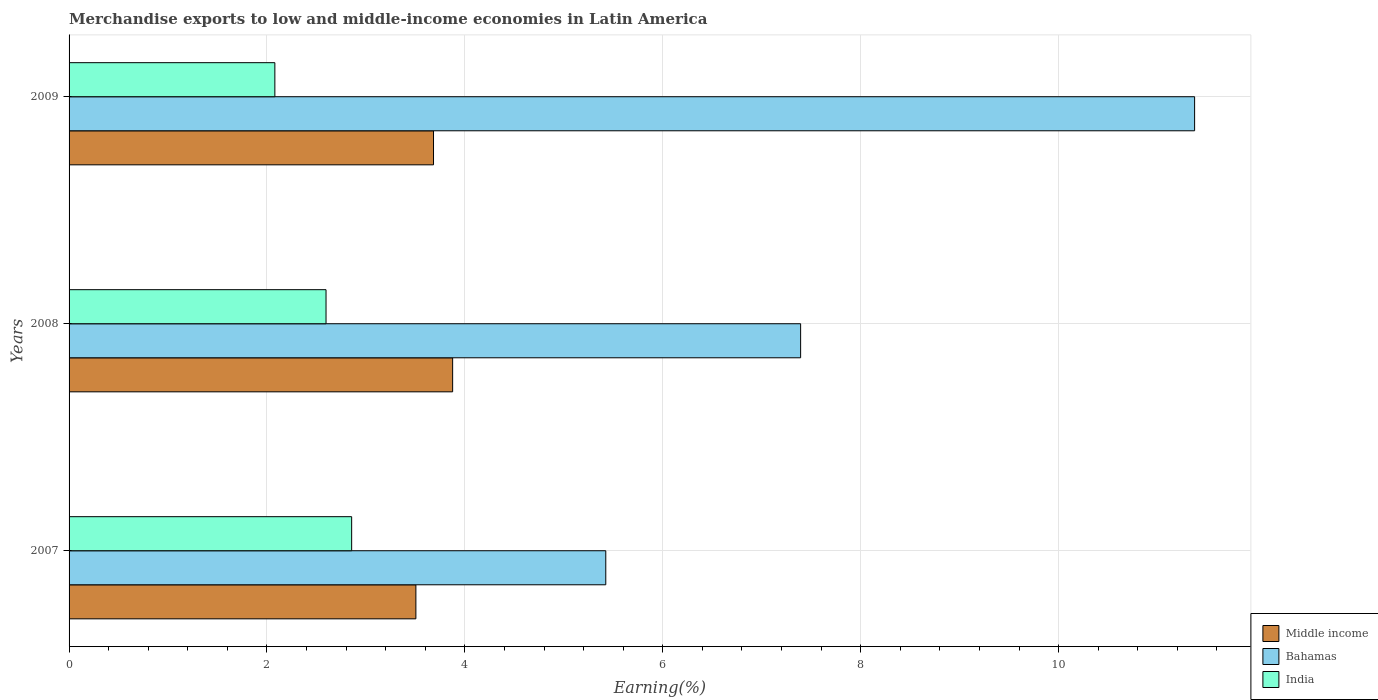How many different coloured bars are there?
Make the answer very short. 3. Are the number of bars per tick equal to the number of legend labels?
Ensure brevity in your answer.  Yes. Are the number of bars on each tick of the Y-axis equal?
Provide a short and direct response. Yes. How many bars are there on the 2nd tick from the top?
Make the answer very short. 3. How many bars are there on the 2nd tick from the bottom?
Provide a short and direct response. 3. In how many cases, is the number of bars for a given year not equal to the number of legend labels?
Make the answer very short. 0. What is the percentage of amount earned from merchandise exports in Bahamas in 2007?
Make the answer very short. 5.42. Across all years, what is the maximum percentage of amount earned from merchandise exports in Middle income?
Offer a very short reply. 3.88. Across all years, what is the minimum percentage of amount earned from merchandise exports in Middle income?
Offer a terse response. 3.5. In which year was the percentage of amount earned from merchandise exports in India maximum?
Your answer should be very brief. 2007. What is the total percentage of amount earned from merchandise exports in Middle income in the graph?
Offer a very short reply. 11.06. What is the difference between the percentage of amount earned from merchandise exports in Bahamas in 2008 and that in 2009?
Provide a short and direct response. -3.98. What is the difference between the percentage of amount earned from merchandise exports in India in 2009 and the percentage of amount earned from merchandise exports in Middle income in 2007?
Keep it short and to the point. -1.43. What is the average percentage of amount earned from merchandise exports in Bahamas per year?
Provide a succinct answer. 8.06. In the year 2009, what is the difference between the percentage of amount earned from merchandise exports in India and percentage of amount earned from merchandise exports in Bahamas?
Your answer should be compact. -9.29. In how many years, is the percentage of amount earned from merchandise exports in Bahamas greater than 9.2 %?
Provide a short and direct response. 1. What is the ratio of the percentage of amount earned from merchandise exports in Bahamas in 2007 to that in 2009?
Provide a succinct answer. 0.48. What is the difference between the highest and the second highest percentage of amount earned from merchandise exports in India?
Provide a succinct answer. 0.26. What is the difference between the highest and the lowest percentage of amount earned from merchandise exports in Middle income?
Ensure brevity in your answer.  0.37. Is it the case that in every year, the sum of the percentage of amount earned from merchandise exports in Middle income and percentage of amount earned from merchandise exports in Bahamas is greater than the percentage of amount earned from merchandise exports in India?
Provide a short and direct response. Yes. Are all the bars in the graph horizontal?
Your answer should be very brief. Yes. How many years are there in the graph?
Provide a short and direct response. 3. What is the difference between two consecutive major ticks on the X-axis?
Your answer should be very brief. 2. Are the values on the major ticks of X-axis written in scientific E-notation?
Your answer should be compact. No. Does the graph contain any zero values?
Provide a short and direct response. No. Does the graph contain grids?
Provide a short and direct response. Yes. Where does the legend appear in the graph?
Provide a succinct answer. Bottom right. How are the legend labels stacked?
Ensure brevity in your answer.  Vertical. What is the title of the graph?
Keep it short and to the point. Merchandise exports to low and middle-income economies in Latin America. What is the label or title of the X-axis?
Make the answer very short. Earning(%). What is the label or title of the Y-axis?
Offer a terse response. Years. What is the Earning(%) in Middle income in 2007?
Offer a terse response. 3.5. What is the Earning(%) of Bahamas in 2007?
Make the answer very short. 5.42. What is the Earning(%) of India in 2007?
Offer a very short reply. 2.86. What is the Earning(%) in Middle income in 2008?
Ensure brevity in your answer.  3.88. What is the Earning(%) of Bahamas in 2008?
Offer a terse response. 7.39. What is the Earning(%) of India in 2008?
Offer a terse response. 2.6. What is the Earning(%) in Middle income in 2009?
Provide a succinct answer. 3.68. What is the Earning(%) in Bahamas in 2009?
Make the answer very short. 11.37. What is the Earning(%) of India in 2009?
Ensure brevity in your answer.  2.08. Across all years, what is the maximum Earning(%) of Middle income?
Provide a succinct answer. 3.88. Across all years, what is the maximum Earning(%) in Bahamas?
Provide a succinct answer. 11.37. Across all years, what is the maximum Earning(%) of India?
Provide a short and direct response. 2.86. Across all years, what is the minimum Earning(%) of Middle income?
Keep it short and to the point. 3.5. Across all years, what is the minimum Earning(%) of Bahamas?
Provide a succinct answer. 5.42. Across all years, what is the minimum Earning(%) in India?
Give a very brief answer. 2.08. What is the total Earning(%) of Middle income in the graph?
Keep it short and to the point. 11.06. What is the total Earning(%) in Bahamas in the graph?
Keep it short and to the point. 24.19. What is the total Earning(%) of India in the graph?
Provide a short and direct response. 7.53. What is the difference between the Earning(%) in Middle income in 2007 and that in 2008?
Your answer should be compact. -0.37. What is the difference between the Earning(%) of Bahamas in 2007 and that in 2008?
Provide a succinct answer. -1.97. What is the difference between the Earning(%) of India in 2007 and that in 2008?
Make the answer very short. 0.26. What is the difference between the Earning(%) of Middle income in 2007 and that in 2009?
Make the answer very short. -0.18. What is the difference between the Earning(%) in Bahamas in 2007 and that in 2009?
Keep it short and to the point. -5.95. What is the difference between the Earning(%) in India in 2007 and that in 2009?
Offer a terse response. 0.78. What is the difference between the Earning(%) of Middle income in 2008 and that in 2009?
Your response must be concise. 0.19. What is the difference between the Earning(%) of Bahamas in 2008 and that in 2009?
Your answer should be very brief. -3.98. What is the difference between the Earning(%) of India in 2008 and that in 2009?
Ensure brevity in your answer.  0.52. What is the difference between the Earning(%) in Middle income in 2007 and the Earning(%) in Bahamas in 2008?
Provide a succinct answer. -3.89. What is the difference between the Earning(%) in Middle income in 2007 and the Earning(%) in India in 2008?
Provide a succinct answer. 0.91. What is the difference between the Earning(%) in Bahamas in 2007 and the Earning(%) in India in 2008?
Make the answer very short. 2.83. What is the difference between the Earning(%) of Middle income in 2007 and the Earning(%) of Bahamas in 2009?
Offer a very short reply. -7.87. What is the difference between the Earning(%) of Middle income in 2007 and the Earning(%) of India in 2009?
Provide a short and direct response. 1.43. What is the difference between the Earning(%) in Bahamas in 2007 and the Earning(%) in India in 2009?
Make the answer very short. 3.34. What is the difference between the Earning(%) of Middle income in 2008 and the Earning(%) of Bahamas in 2009?
Your answer should be very brief. -7.5. What is the difference between the Earning(%) of Middle income in 2008 and the Earning(%) of India in 2009?
Offer a very short reply. 1.8. What is the difference between the Earning(%) of Bahamas in 2008 and the Earning(%) of India in 2009?
Your answer should be very brief. 5.31. What is the average Earning(%) in Middle income per year?
Your answer should be very brief. 3.69. What is the average Earning(%) in Bahamas per year?
Offer a very short reply. 8.06. What is the average Earning(%) in India per year?
Your answer should be very brief. 2.51. In the year 2007, what is the difference between the Earning(%) in Middle income and Earning(%) in Bahamas?
Give a very brief answer. -1.92. In the year 2007, what is the difference between the Earning(%) in Middle income and Earning(%) in India?
Keep it short and to the point. 0.65. In the year 2007, what is the difference between the Earning(%) of Bahamas and Earning(%) of India?
Your answer should be very brief. 2.57. In the year 2008, what is the difference between the Earning(%) of Middle income and Earning(%) of Bahamas?
Give a very brief answer. -3.52. In the year 2008, what is the difference between the Earning(%) of Middle income and Earning(%) of India?
Your answer should be compact. 1.28. In the year 2008, what is the difference between the Earning(%) in Bahamas and Earning(%) in India?
Provide a succinct answer. 4.8. In the year 2009, what is the difference between the Earning(%) in Middle income and Earning(%) in Bahamas?
Offer a terse response. -7.69. In the year 2009, what is the difference between the Earning(%) of Middle income and Earning(%) of India?
Offer a terse response. 1.6. In the year 2009, what is the difference between the Earning(%) of Bahamas and Earning(%) of India?
Keep it short and to the point. 9.29. What is the ratio of the Earning(%) in Middle income in 2007 to that in 2008?
Ensure brevity in your answer.  0.9. What is the ratio of the Earning(%) in Bahamas in 2007 to that in 2008?
Your answer should be very brief. 0.73. What is the ratio of the Earning(%) of India in 2007 to that in 2008?
Make the answer very short. 1.1. What is the ratio of the Earning(%) of Middle income in 2007 to that in 2009?
Offer a very short reply. 0.95. What is the ratio of the Earning(%) of Bahamas in 2007 to that in 2009?
Your response must be concise. 0.48. What is the ratio of the Earning(%) of India in 2007 to that in 2009?
Keep it short and to the point. 1.37. What is the ratio of the Earning(%) of Middle income in 2008 to that in 2009?
Your answer should be very brief. 1.05. What is the ratio of the Earning(%) of Bahamas in 2008 to that in 2009?
Give a very brief answer. 0.65. What is the ratio of the Earning(%) in India in 2008 to that in 2009?
Keep it short and to the point. 1.25. What is the difference between the highest and the second highest Earning(%) in Middle income?
Give a very brief answer. 0.19. What is the difference between the highest and the second highest Earning(%) of Bahamas?
Provide a short and direct response. 3.98. What is the difference between the highest and the second highest Earning(%) in India?
Make the answer very short. 0.26. What is the difference between the highest and the lowest Earning(%) in Middle income?
Give a very brief answer. 0.37. What is the difference between the highest and the lowest Earning(%) in Bahamas?
Keep it short and to the point. 5.95. What is the difference between the highest and the lowest Earning(%) of India?
Your response must be concise. 0.78. 